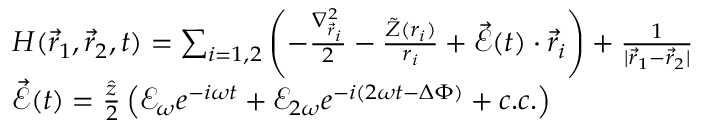<formula> <loc_0><loc_0><loc_500><loc_500>\begin{array} { r l } & { H ( \vec { r } _ { 1 } , \vec { r } _ { 2 } , t ) = \sum _ { i = 1 , 2 } \left ( - \frac { \nabla _ { \vec { r } _ { i } } ^ { 2 } } { 2 } - \frac { \tilde { Z } ( r _ { i } ) } { r _ { i } } + \vec { \mathcal { E } } ( t ) \cdot \vec { r } _ { i } \right ) + \frac { 1 } { | \vec { r } _ { 1 } - \vec { r } _ { 2 } | } } \\ & { \vec { \mathcal { E } } ( t ) = \frac { \hat { z } } { 2 } \left ( \mathcal { E } _ { \omega } e ^ { - i \omega t } + \mathcal { E } _ { 2 \omega } e ^ { - i ( 2 \omega t - \Delta \Phi ) } + c . c . \right ) } \end{array}</formula> 